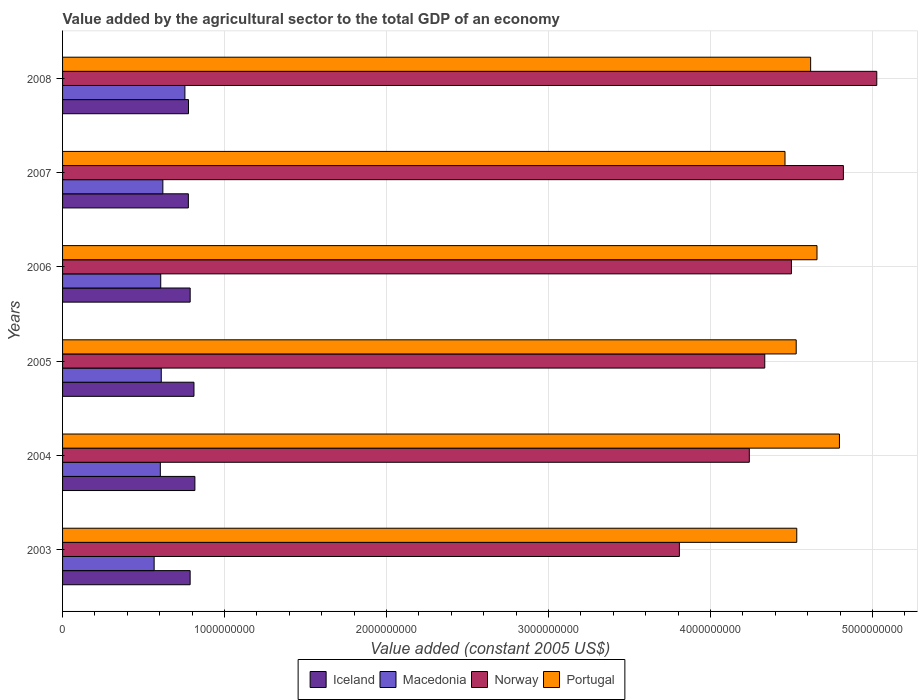How many different coloured bars are there?
Give a very brief answer. 4. How many groups of bars are there?
Your answer should be very brief. 6. How many bars are there on the 2nd tick from the top?
Provide a succinct answer. 4. How many bars are there on the 4th tick from the bottom?
Make the answer very short. 4. In how many cases, is the number of bars for a given year not equal to the number of legend labels?
Your answer should be very brief. 0. What is the value added by the agricultural sector in Portugal in 2006?
Give a very brief answer. 4.66e+09. Across all years, what is the maximum value added by the agricultural sector in Macedonia?
Ensure brevity in your answer.  7.55e+08. Across all years, what is the minimum value added by the agricultural sector in Macedonia?
Provide a short and direct response. 5.65e+08. In which year was the value added by the agricultural sector in Norway maximum?
Offer a terse response. 2008. In which year was the value added by the agricultural sector in Iceland minimum?
Provide a short and direct response. 2007. What is the total value added by the agricultural sector in Iceland in the graph?
Ensure brevity in your answer.  4.76e+09. What is the difference between the value added by the agricultural sector in Macedonia in 2004 and that in 2005?
Your answer should be compact. -5.80e+06. What is the difference between the value added by the agricultural sector in Macedonia in 2005 and the value added by the agricultural sector in Portugal in 2007?
Ensure brevity in your answer.  -3.85e+09. What is the average value added by the agricultural sector in Iceland per year?
Keep it short and to the point. 7.93e+08. In the year 2004, what is the difference between the value added by the agricultural sector in Macedonia and value added by the agricultural sector in Portugal?
Make the answer very short. -4.19e+09. What is the ratio of the value added by the agricultural sector in Iceland in 2005 to that in 2006?
Ensure brevity in your answer.  1.03. Is the difference between the value added by the agricultural sector in Macedonia in 2007 and 2008 greater than the difference between the value added by the agricultural sector in Portugal in 2007 and 2008?
Your answer should be very brief. Yes. What is the difference between the highest and the second highest value added by the agricultural sector in Portugal?
Your answer should be very brief. 1.38e+08. What is the difference between the highest and the lowest value added by the agricultural sector in Macedonia?
Make the answer very short. 1.90e+08. In how many years, is the value added by the agricultural sector in Norway greater than the average value added by the agricultural sector in Norway taken over all years?
Your answer should be compact. 3. What does the 3rd bar from the top in 2003 represents?
Your answer should be compact. Macedonia. Is it the case that in every year, the sum of the value added by the agricultural sector in Macedonia and value added by the agricultural sector in Iceland is greater than the value added by the agricultural sector in Portugal?
Your answer should be very brief. No. How many bars are there?
Make the answer very short. 24. How many years are there in the graph?
Ensure brevity in your answer.  6. What is the difference between two consecutive major ticks on the X-axis?
Make the answer very short. 1.00e+09. Are the values on the major ticks of X-axis written in scientific E-notation?
Offer a terse response. No. Does the graph contain any zero values?
Make the answer very short. No. Does the graph contain grids?
Offer a terse response. Yes. Where does the legend appear in the graph?
Provide a succinct answer. Bottom center. How are the legend labels stacked?
Your answer should be compact. Horizontal. What is the title of the graph?
Make the answer very short. Value added by the agricultural sector to the total GDP of an economy. Does "Panama" appear as one of the legend labels in the graph?
Keep it short and to the point. No. What is the label or title of the X-axis?
Keep it short and to the point. Value added (constant 2005 US$). What is the label or title of the Y-axis?
Keep it short and to the point. Years. What is the Value added (constant 2005 US$) in Iceland in 2003?
Your response must be concise. 7.88e+08. What is the Value added (constant 2005 US$) of Macedonia in 2003?
Offer a very short reply. 5.65e+08. What is the Value added (constant 2005 US$) of Norway in 2003?
Your answer should be compact. 3.81e+09. What is the Value added (constant 2005 US$) of Portugal in 2003?
Keep it short and to the point. 4.53e+09. What is the Value added (constant 2005 US$) of Iceland in 2004?
Offer a very short reply. 8.17e+08. What is the Value added (constant 2005 US$) of Macedonia in 2004?
Keep it short and to the point. 6.04e+08. What is the Value added (constant 2005 US$) in Norway in 2004?
Offer a very short reply. 4.24e+09. What is the Value added (constant 2005 US$) of Portugal in 2004?
Provide a short and direct response. 4.80e+09. What is the Value added (constant 2005 US$) of Iceland in 2005?
Offer a very short reply. 8.11e+08. What is the Value added (constant 2005 US$) in Macedonia in 2005?
Keep it short and to the point. 6.09e+08. What is the Value added (constant 2005 US$) of Norway in 2005?
Ensure brevity in your answer.  4.33e+09. What is the Value added (constant 2005 US$) in Portugal in 2005?
Make the answer very short. 4.53e+09. What is the Value added (constant 2005 US$) in Iceland in 2006?
Your answer should be compact. 7.88e+08. What is the Value added (constant 2005 US$) in Macedonia in 2006?
Provide a succinct answer. 6.06e+08. What is the Value added (constant 2005 US$) in Norway in 2006?
Provide a succinct answer. 4.50e+09. What is the Value added (constant 2005 US$) of Portugal in 2006?
Your response must be concise. 4.66e+09. What is the Value added (constant 2005 US$) in Iceland in 2007?
Provide a short and direct response. 7.77e+08. What is the Value added (constant 2005 US$) of Macedonia in 2007?
Your response must be concise. 6.19e+08. What is the Value added (constant 2005 US$) of Norway in 2007?
Give a very brief answer. 4.82e+09. What is the Value added (constant 2005 US$) of Portugal in 2007?
Ensure brevity in your answer.  4.46e+09. What is the Value added (constant 2005 US$) in Iceland in 2008?
Provide a succinct answer. 7.77e+08. What is the Value added (constant 2005 US$) in Macedonia in 2008?
Offer a very short reply. 7.55e+08. What is the Value added (constant 2005 US$) of Norway in 2008?
Your response must be concise. 5.03e+09. What is the Value added (constant 2005 US$) of Portugal in 2008?
Provide a short and direct response. 4.62e+09. Across all years, what is the maximum Value added (constant 2005 US$) of Iceland?
Your response must be concise. 8.17e+08. Across all years, what is the maximum Value added (constant 2005 US$) in Macedonia?
Your answer should be very brief. 7.55e+08. Across all years, what is the maximum Value added (constant 2005 US$) in Norway?
Your answer should be very brief. 5.03e+09. Across all years, what is the maximum Value added (constant 2005 US$) of Portugal?
Keep it short and to the point. 4.80e+09. Across all years, what is the minimum Value added (constant 2005 US$) of Iceland?
Offer a very short reply. 7.77e+08. Across all years, what is the minimum Value added (constant 2005 US$) in Macedonia?
Give a very brief answer. 5.65e+08. Across all years, what is the minimum Value added (constant 2005 US$) in Norway?
Keep it short and to the point. 3.81e+09. Across all years, what is the minimum Value added (constant 2005 US$) of Portugal?
Provide a short and direct response. 4.46e+09. What is the total Value added (constant 2005 US$) of Iceland in the graph?
Offer a very short reply. 4.76e+09. What is the total Value added (constant 2005 US$) of Macedonia in the graph?
Your answer should be very brief. 3.76e+09. What is the total Value added (constant 2005 US$) of Norway in the graph?
Provide a succinct answer. 2.67e+1. What is the total Value added (constant 2005 US$) in Portugal in the graph?
Your answer should be very brief. 2.76e+1. What is the difference between the Value added (constant 2005 US$) in Iceland in 2003 and that in 2004?
Provide a short and direct response. -2.93e+07. What is the difference between the Value added (constant 2005 US$) of Macedonia in 2003 and that in 2004?
Ensure brevity in your answer.  -3.82e+07. What is the difference between the Value added (constant 2005 US$) of Norway in 2003 and that in 2004?
Your response must be concise. -4.32e+08. What is the difference between the Value added (constant 2005 US$) of Portugal in 2003 and that in 2004?
Your answer should be compact. -2.63e+08. What is the difference between the Value added (constant 2005 US$) of Iceland in 2003 and that in 2005?
Your answer should be very brief. -2.36e+07. What is the difference between the Value added (constant 2005 US$) in Macedonia in 2003 and that in 2005?
Make the answer very short. -4.40e+07. What is the difference between the Value added (constant 2005 US$) of Norway in 2003 and that in 2005?
Ensure brevity in your answer.  -5.27e+08. What is the difference between the Value added (constant 2005 US$) in Portugal in 2003 and that in 2005?
Provide a short and direct response. 3.53e+06. What is the difference between the Value added (constant 2005 US$) in Iceland in 2003 and that in 2006?
Offer a very short reply. -1.22e+05. What is the difference between the Value added (constant 2005 US$) of Macedonia in 2003 and that in 2006?
Your response must be concise. -4.07e+07. What is the difference between the Value added (constant 2005 US$) in Norway in 2003 and that in 2006?
Make the answer very short. -6.92e+08. What is the difference between the Value added (constant 2005 US$) of Portugal in 2003 and that in 2006?
Ensure brevity in your answer.  -1.25e+08. What is the difference between the Value added (constant 2005 US$) of Iceland in 2003 and that in 2007?
Make the answer very short. 1.11e+07. What is the difference between the Value added (constant 2005 US$) of Macedonia in 2003 and that in 2007?
Give a very brief answer. -5.37e+07. What is the difference between the Value added (constant 2005 US$) of Norway in 2003 and that in 2007?
Offer a very short reply. -1.01e+09. What is the difference between the Value added (constant 2005 US$) in Portugal in 2003 and that in 2007?
Keep it short and to the point. 7.26e+07. What is the difference between the Value added (constant 2005 US$) of Iceland in 2003 and that in 2008?
Offer a terse response. 1.02e+07. What is the difference between the Value added (constant 2005 US$) in Macedonia in 2003 and that in 2008?
Your response must be concise. -1.90e+08. What is the difference between the Value added (constant 2005 US$) in Norway in 2003 and that in 2008?
Provide a succinct answer. -1.22e+09. What is the difference between the Value added (constant 2005 US$) of Portugal in 2003 and that in 2008?
Your response must be concise. -8.56e+07. What is the difference between the Value added (constant 2005 US$) in Iceland in 2004 and that in 2005?
Your answer should be very brief. 5.69e+06. What is the difference between the Value added (constant 2005 US$) of Macedonia in 2004 and that in 2005?
Your answer should be compact. -5.80e+06. What is the difference between the Value added (constant 2005 US$) in Norway in 2004 and that in 2005?
Offer a very short reply. -9.55e+07. What is the difference between the Value added (constant 2005 US$) in Portugal in 2004 and that in 2005?
Provide a short and direct response. 2.67e+08. What is the difference between the Value added (constant 2005 US$) in Iceland in 2004 and that in 2006?
Ensure brevity in your answer.  2.92e+07. What is the difference between the Value added (constant 2005 US$) in Macedonia in 2004 and that in 2006?
Provide a succinct answer. -2.50e+06. What is the difference between the Value added (constant 2005 US$) in Norway in 2004 and that in 2006?
Ensure brevity in your answer.  -2.60e+08. What is the difference between the Value added (constant 2005 US$) of Portugal in 2004 and that in 2006?
Offer a very short reply. 1.38e+08. What is the difference between the Value added (constant 2005 US$) in Iceland in 2004 and that in 2007?
Your answer should be compact. 4.04e+07. What is the difference between the Value added (constant 2005 US$) in Macedonia in 2004 and that in 2007?
Provide a succinct answer. -1.56e+07. What is the difference between the Value added (constant 2005 US$) in Norway in 2004 and that in 2007?
Provide a succinct answer. -5.81e+08. What is the difference between the Value added (constant 2005 US$) of Portugal in 2004 and that in 2007?
Provide a short and direct response. 3.36e+08. What is the difference between the Value added (constant 2005 US$) in Iceland in 2004 and that in 2008?
Your answer should be very brief. 3.94e+07. What is the difference between the Value added (constant 2005 US$) in Macedonia in 2004 and that in 2008?
Offer a very short reply. -1.52e+08. What is the difference between the Value added (constant 2005 US$) of Norway in 2004 and that in 2008?
Keep it short and to the point. -7.87e+08. What is the difference between the Value added (constant 2005 US$) of Portugal in 2004 and that in 2008?
Give a very brief answer. 1.78e+08. What is the difference between the Value added (constant 2005 US$) in Iceland in 2005 and that in 2006?
Give a very brief answer. 2.35e+07. What is the difference between the Value added (constant 2005 US$) in Macedonia in 2005 and that in 2006?
Offer a very short reply. 3.31e+06. What is the difference between the Value added (constant 2005 US$) in Norway in 2005 and that in 2006?
Provide a succinct answer. -1.65e+08. What is the difference between the Value added (constant 2005 US$) of Portugal in 2005 and that in 2006?
Your answer should be compact. -1.28e+08. What is the difference between the Value added (constant 2005 US$) of Iceland in 2005 and that in 2007?
Offer a very short reply. 3.47e+07. What is the difference between the Value added (constant 2005 US$) in Macedonia in 2005 and that in 2007?
Give a very brief answer. -9.75e+06. What is the difference between the Value added (constant 2005 US$) in Norway in 2005 and that in 2007?
Offer a terse response. -4.85e+08. What is the difference between the Value added (constant 2005 US$) in Portugal in 2005 and that in 2007?
Your answer should be compact. 6.91e+07. What is the difference between the Value added (constant 2005 US$) of Iceland in 2005 and that in 2008?
Make the answer very short. 3.37e+07. What is the difference between the Value added (constant 2005 US$) in Macedonia in 2005 and that in 2008?
Offer a very short reply. -1.46e+08. What is the difference between the Value added (constant 2005 US$) in Norway in 2005 and that in 2008?
Give a very brief answer. -6.92e+08. What is the difference between the Value added (constant 2005 US$) of Portugal in 2005 and that in 2008?
Provide a short and direct response. -8.92e+07. What is the difference between the Value added (constant 2005 US$) of Iceland in 2006 and that in 2007?
Ensure brevity in your answer.  1.12e+07. What is the difference between the Value added (constant 2005 US$) of Macedonia in 2006 and that in 2007?
Offer a terse response. -1.31e+07. What is the difference between the Value added (constant 2005 US$) of Norway in 2006 and that in 2007?
Provide a succinct answer. -3.21e+08. What is the difference between the Value added (constant 2005 US$) of Portugal in 2006 and that in 2007?
Provide a succinct answer. 1.98e+08. What is the difference between the Value added (constant 2005 US$) in Iceland in 2006 and that in 2008?
Ensure brevity in your answer.  1.03e+07. What is the difference between the Value added (constant 2005 US$) in Macedonia in 2006 and that in 2008?
Provide a succinct answer. -1.49e+08. What is the difference between the Value added (constant 2005 US$) in Norway in 2006 and that in 2008?
Ensure brevity in your answer.  -5.27e+08. What is the difference between the Value added (constant 2005 US$) of Portugal in 2006 and that in 2008?
Your answer should be very brief. 3.93e+07. What is the difference between the Value added (constant 2005 US$) of Iceland in 2007 and that in 2008?
Offer a terse response. -9.22e+05. What is the difference between the Value added (constant 2005 US$) in Macedonia in 2007 and that in 2008?
Offer a very short reply. -1.36e+08. What is the difference between the Value added (constant 2005 US$) of Norway in 2007 and that in 2008?
Offer a terse response. -2.06e+08. What is the difference between the Value added (constant 2005 US$) of Portugal in 2007 and that in 2008?
Make the answer very short. -1.58e+08. What is the difference between the Value added (constant 2005 US$) of Iceland in 2003 and the Value added (constant 2005 US$) of Macedonia in 2004?
Keep it short and to the point. 1.84e+08. What is the difference between the Value added (constant 2005 US$) in Iceland in 2003 and the Value added (constant 2005 US$) in Norway in 2004?
Provide a short and direct response. -3.45e+09. What is the difference between the Value added (constant 2005 US$) in Iceland in 2003 and the Value added (constant 2005 US$) in Portugal in 2004?
Offer a very short reply. -4.01e+09. What is the difference between the Value added (constant 2005 US$) of Macedonia in 2003 and the Value added (constant 2005 US$) of Norway in 2004?
Keep it short and to the point. -3.67e+09. What is the difference between the Value added (constant 2005 US$) in Macedonia in 2003 and the Value added (constant 2005 US$) in Portugal in 2004?
Give a very brief answer. -4.23e+09. What is the difference between the Value added (constant 2005 US$) in Norway in 2003 and the Value added (constant 2005 US$) in Portugal in 2004?
Offer a terse response. -9.88e+08. What is the difference between the Value added (constant 2005 US$) of Iceland in 2003 and the Value added (constant 2005 US$) of Macedonia in 2005?
Your answer should be very brief. 1.78e+08. What is the difference between the Value added (constant 2005 US$) of Iceland in 2003 and the Value added (constant 2005 US$) of Norway in 2005?
Your answer should be very brief. -3.55e+09. What is the difference between the Value added (constant 2005 US$) in Iceland in 2003 and the Value added (constant 2005 US$) in Portugal in 2005?
Offer a very short reply. -3.74e+09. What is the difference between the Value added (constant 2005 US$) in Macedonia in 2003 and the Value added (constant 2005 US$) in Norway in 2005?
Provide a short and direct response. -3.77e+09. What is the difference between the Value added (constant 2005 US$) in Macedonia in 2003 and the Value added (constant 2005 US$) in Portugal in 2005?
Provide a succinct answer. -3.96e+09. What is the difference between the Value added (constant 2005 US$) in Norway in 2003 and the Value added (constant 2005 US$) in Portugal in 2005?
Ensure brevity in your answer.  -7.21e+08. What is the difference between the Value added (constant 2005 US$) of Iceland in 2003 and the Value added (constant 2005 US$) of Macedonia in 2006?
Keep it short and to the point. 1.82e+08. What is the difference between the Value added (constant 2005 US$) in Iceland in 2003 and the Value added (constant 2005 US$) in Norway in 2006?
Ensure brevity in your answer.  -3.71e+09. What is the difference between the Value added (constant 2005 US$) of Iceland in 2003 and the Value added (constant 2005 US$) of Portugal in 2006?
Offer a very short reply. -3.87e+09. What is the difference between the Value added (constant 2005 US$) of Macedonia in 2003 and the Value added (constant 2005 US$) of Norway in 2006?
Your answer should be very brief. -3.93e+09. What is the difference between the Value added (constant 2005 US$) of Macedonia in 2003 and the Value added (constant 2005 US$) of Portugal in 2006?
Your answer should be very brief. -4.09e+09. What is the difference between the Value added (constant 2005 US$) of Norway in 2003 and the Value added (constant 2005 US$) of Portugal in 2006?
Your answer should be compact. -8.50e+08. What is the difference between the Value added (constant 2005 US$) of Iceland in 2003 and the Value added (constant 2005 US$) of Macedonia in 2007?
Offer a terse response. 1.69e+08. What is the difference between the Value added (constant 2005 US$) of Iceland in 2003 and the Value added (constant 2005 US$) of Norway in 2007?
Provide a short and direct response. -4.03e+09. What is the difference between the Value added (constant 2005 US$) in Iceland in 2003 and the Value added (constant 2005 US$) in Portugal in 2007?
Your answer should be very brief. -3.67e+09. What is the difference between the Value added (constant 2005 US$) of Macedonia in 2003 and the Value added (constant 2005 US$) of Norway in 2007?
Provide a short and direct response. -4.25e+09. What is the difference between the Value added (constant 2005 US$) in Macedonia in 2003 and the Value added (constant 2005 US$) in Portugal in 2007?
Make the answer very short. -3.89e+09. What is the difference between the Value added (constant 2005 US$) of Norway in 2003 and the Value added (constant 2005 US$) of Portugal in 2007?
Give a very brief answer. -6.52e+08. What is the difference between the Value added (constant 2005 US$) in Iceland in 2003 and the Value added (constant 2005 US$) in Macedonia in 2008?
Make the answer very short. 3.24e+07. What is the difference between the Value added (constant 2005 US$) of Iceland in 2003 and the Value added (constant 2005 US$) of Norway in 2008?
Your response must be concise. -4.24e+09. What is the difference between the Value added (constant 2005 US$) in Iceland in 2003 and the Value added (constant 2005 US$) in Portugal in 2008?
Offer a very short reply. -3.83e+09. What is the difference between the Value added (constant 2005 US$) in Macedonia in 2003 and the Value added (constant 2005 US$) in Norway in 2008?
Your response must be concise. -4.46e+09. What is the difference between the Value added (constant 2005 US$) of Macedonia in 2003 and the Value added (constant 2005 US$) of Portugal in 2008?
Your response must be concise. -4.05e+09. What is the difference between the Value added (constant 2005 US$) in Norway in 2003 and the Value added (constant 2005 US$) in Portugal in 2008?
Your response must be concise. -8.10e+08. What is the difference between the Value added (constant 2005 US$) of Iceland in 2004 and the Value added (constant 2005 US$) of Macedonia in 2005?
Make the answer very short. 2.08e+08. What is the difference between the Value added (constant 2005 US$) in Iceland in 2004 and the Value added (constant 2005 US$) in Norway in 2005?
Your response must be concise. -3.52e+09. What is the difference between the Value added (constant 2005 US$) of Iceland in 2004 and the Value added (constant 2005 US$) of Portugal in 2005?
Make the answer very short. -3.71e+09. What is the difference between the Value added (constant 2005 US$) of Macedonia in 2004 and the Value added (constant 2005 US$) of Norway in 2005?
Your answer should be compact. -3.73e+09. What is the difference between the Value added (constant 2005 US$) in Macedonia in 2004 and the Value added (constant 2005 US$) in Portugal in 2005?
Provide a short and direct response. -3.93e+09. What is the difference between the Value added (constant 2005 US$) in Norway in 2004 and the Value added (constant 2005 US$) in Portugal in 2005?
Give a very brief answer. -2.90e+08. What is the difference between the Value added (constant 2005 US$) in Iceland in 2004 and the Value added (constant 2005 US$) in Macedonia in 2006?
Make the answer very short. 2.11e+08. What is the difference between the Value added (constant 2005 US$) in Iceland in 2004 and the Value added (constant 2005 US$) in Norway in 2006?
Your response must be concise. -3.68e+09. What is the difference between the Value added (constant 2005 US$) in Iceland in 2004 and the Value added (constant 2005 US$) in Portugal in 2006?
Your answer should be compact. -3.84e+09. What is the difference between the Value added (constant 2005 US$) of Macedonia in 2004 and the Value added (constant 2005 US$) of Norway in 2006?
Keep it short and to the point. -3.90e+09. What is the difference between the Value added (constant 2005 US$) of Macedonia in 2004 and the Value added (constant 2005 US$) of Portugal in 2006?
Offer a very short reply. -4.05e+09. What is the difference between the Value added (constant 2005 US$) in Norway in 2004 and the Value added (constant 2005 US$) in Portugal in 2006?
Your response must be concise. -4.18e+08. What is the difference between the Value added (constant 2005 US$) of Iceland in 2004 and the Value added (constant 2005 US$) of Macedonia in 2007?
Give a very brief answer. 1.98e+08. What is the difference between the Value added (constant 2005 US$) in Iceland in 2004 and the Value added (constant 2005 US$) in Norway in 2007?
Offer a very short reply. -4.00e+09. What is the difference between the Value added (constant 2005 US$) in Iceland in 2004 and the Value added (constant 2005 US$) in Portugal in 2007?
Ensure brevity in your answer.  -3.64e+09. What is the difference between the Value added (constant 2005 US$) of Macedonia in 2004 and the Value added (constant 2005 US$) of Norway in 2007?
Offer a terse response. -4.22e+09. What is the difference between the Value added (constant 2005 US$) of Macedonia in 2004 and the Value added (constant 2005 US$) of Portugal in 2007?
Make the answer very short. -3.86e+09. What is the difference between the Value added (constant 2005 US$) in Norway in 2004 and the Value added (constant 2005 US$) in Portugal in 2007?
Your answer should be compact. -2.20e+08. What is the difference between the Value added (constant 2005 US$) in Iceland in 2004 and the Value added (constant 2005 US$) in Macedonia in 2008?
Ensure brevity in your answer.  6.17e+07. What is the difference between the Value added (constant 2005 US$) in Iceland in 2004 and the Value added (constant 2005 US$) in Norway in 2008?
Make the answer very short. -4.21e+09. What is the difference between the Value added (constant 2005 US$) of Iceland in 2004 and the Value added (constant 2005 US$) of Portugal in 2008?
Make the answer very short. -3.80e+09. What is the difference between the Value added (constant 2005 US$) of Macedonia in 2004 and the Value added (constant 2005 US$) of Norway in 2008?
Your answer should be very brief. -4.42e+09. What is the difference between the Value added (constant 2005 US$) in Macedonia in 2004 and the Value added (constant 2005 US$) in Portugal in 2008?
Offer a very short reply. -4.01e+09. What is the difference between the Value added (constant 2005 US$) in Norway in 2004 and the Value added (constant 2005 US$) in Portugal in 2008?
Offer a very short reply. -3.79e+08. What is the difference between the Value added (constant 2005 US$) in Iceland in 2005 and the Value added (constant 2005 US$) in Macedonia in 2006?
Your response must be concise. 2.05e+08. What is the difference between the Value added (constant 2005 US$) of Iceland in 2005 and the Value added (constant 2005 US$) of Norway in 2006?
Provide a short and direct response. -3.69e+09. What is the difference between the Value added (constant 2005 US$) in Iceland in 2005 and the Value added (constant 2005 US$) in Portugal in 2006?
Keep it short and to the point. -3.85e+09. What is the difference between the Value added (constant 2005 US$) in Macedonia in 2005 and the Value added (constant 2005 US$) in Norway in 2006?
Your answer should be very brief. -3.89e+09. What is the difference between the Value added (constant 2005 US$) in Macedonia in 2005 and the Value added (constant 2005 US$) in Portugal in 2006?
Ensure brevity in your answer.  -4.05e+09. What is the difference between the Value added (constant 2005 US$) in Norway in 2005 and the Value added (constant 2005 US$) in Portugal in 2006?
Offer a terse response. -3.22e+08. What is the difference between the Value added (constant 2005 US$) in Iceland in 2005 and the Value added (constant 2005 US$) in Macedonia in 2007?
Ensure brevity in your answer.  1.92e+08. What is the difference between the Value added (constant 2005 US$) of Iceland in 2005 and the Value added (constant 2005 US$) of Norway in 2007?
Ensure brevity in your answer.  -4.01e+09. What is the difference between the Value added (constant 2005 US$) in Iceland in 2005 and the Value added (constant 2005 US$) in Portugal in 2007?
Your answer should be very brief. -3.65e+09. What is the difference between the Value added (constant 2005 US$) of Macedonia in 2005 and the Value added (constant 2005 US$) of Norway in 2007?
Provide a short and direct response. -4.21e+09. What is the difference between the Value added (constant 2005 US$) in Macedonia in 2005 and the Value added (constant 2005 US$) in Portugal in 2007?
Your response must be concise. -3.85e+09. What is the difference between the Value added (constant 2005 US$) of Norway in 2005 and the Value added (constant 2005 US$) of Portugal in 2007?
Give a very brief answer. -1.25e+08. What is the difference between the Value added (constant 2005 US$) of Iceland in 2005 and the Value added (constant 2005 US$) of Macedonia in 2008?
Ensure brevity in your answer.  5.60e+07. What is the difference between the Value added (constant 2005 US$) of Iceland in 2005 and the Value added (constant 2005 US$) of Norway in 2008?
Provide a succinct answer. -4.22e+09. What is the difference between the Value added (constant 2005 US$) in Iceland in 2005 and the Value added (constant 2005 US$) in Portugal in 2008?
Your answer should be compact. -3.81e+09. What is the difference between the Value added (constant 2005 US$) in Macedonia in 2005 and the Value added (constant 2005 US$) in Norway in 2008?
Your answer should be compact. -4.42e+09. What is the difference between the Value added (constant 2005 US$) in Macedonia in 2005 and the Value added (constant 2005 US$) in Portugal in 2008?
Your response must be concise. -4.01e+09. What is the difference between the Value added (constant 2005 US$) in Norway in 2005 and the Value added (constant 2005 US$) in Portugal in 2008?
Ensure brevity in your answer.  -2.83e+08. What is the difference between the Value added (constant 2005 US$) of Iceland in 2006 and the Value added (constant 2005 US$) of Macedonia in 2007?
Provide a short and direct response. 1.69e+08. What is the difference between the Value added (constant 2005 US$) in Iceland in 2006 and the Value added (constant 2005 US$) in Norway in 2007?
Your answer should be very brief. -4.03e+09. What is the difference between the Value added (constant 2005 US$) of Iceland in 2006 and the Value added (constant 2005 US$) of Portugal in 2007?
Ensure brevity in your answer.  -3.67e+09. What is the difference between the Value added (constant 2005 US$) in Macedonia in 2006 and the Value added (constant 2005 US$) in Norway in 2007?
Ensure brevity in your answer.  -4.21e+09. What is the difference between the Value added (constant 2005 US$) of Macedonia in 2006 and the Value added (constant 2005 US$) of Portugal in 2007?
Your answer should be very brief. -3.85e+09. What is the difference between the Value added (constant 2005 US$) of Norway in 2006 and the Value added (constant 2005 US$) of Portugal in 2007?
Your answer should be very brief. 3.96e+07. What is the difference between the Value added (constant 2005 US$) in Iceland in 2006 and the Value added (constant 2005 US$) in Macedonia in 2008?
Keep it short and to the point. 3.25e+07. What is the difference between the Value added (constant 2005 US$) in Iceland in 2006 and the Value added (constant 2005 US$) in Norway in 2008?
Your response must be concise. -4.24e+09. What is the difference between the Value added (constant 2005 US$) in Iceland in 2006 and the Value added (constant 2005 US$) in Portugal in 2008?
Your response must be concise. -3.83e+09. What is the difference between the Value added (constant 2005 US$) of Macedonia in 2006 and the Value added (constant 2005 US$) of Norway in 2008?
Provide a succinct answer. -4.42e+09. What is the difference between the Value added (constant 2005 US$) of Macedonia in 2006 and the Value added (constant 2005 US$) of Portugal in 2008?
Give a very brief answer. -4.01e+09. What is the difference between the Value added (constant 2005 US$) of Norway in 2006 and the Value added (constant 2005 US$) of Portugal in 2008?
Offer a terse response. -1.19e+08. What is the difference between the Value added (constant 2005 US$) of Iceland in 2007 and the Value added (constant 2005 US$) of Macedonia in 2008?
Your answer should be very brief. 2.13e+07. What is the difference between the Value added (constant 2005 US$) in Iceland in 2007 and the Value added (constant 2005 US$) in Norway in 2008?
Your answer should be compact. -4.25e+09. What is the difference between the Value added (constant 2005 US$) in Iceland in 2007 and the Value added (constant 2005 US$) in Portugal in 2008?
Your answer should be compact. -3.84e+09. What is the difference between the Value added (constant 2005 US$) in Macedonia in 2007 and the Value added (constant 2005 US$) in Norway in 2008?
Your response must be concise. -4.41e+09. What is the difference between the Value added (constant 2005 US$) of Macedonia in 2007 and the Value added (constant 2005 US$) of Portugal in 2008?
Offer a very short reply. -4.00e+09. What is the difference between the Value added (constant 2005 US$) of Norway in 2007 and the Value added (constant 2005 US$) of Portugal in 2008?
Ensure brevity in your answer.  2.02e+08. What is the average Value added (constant 2005 US$) in Iceland per year?
Give a very brief answer. 7.93e+08. What is the average Value added (constant 2005 US$) in Macedonia per year?
Your response must be concise. 6.26e+08. What is the average Value added (constant 2005 US$) of Norway per year?
Keep it short and to the point. 4.45e+09. What is the average Value added (constant 2005 US$) of Portugal per year?
Offer a very short reply. 4.60e+09. In the year 2003, what is the difference between the Value added (constant 2005 US$) in Iceland and Value added (constant 2005 US$) in Macedonia?
Offer a very short reply. 2.22e+08. In the year 2003, what is the difference between the Value added (constant 2005 US$) in Iceland and Value added (constant 2005 US$) in Norway?
Offer a very short reply. -3.02e+09. In the year 2003, what is the difference between the Value added (constant 2005 US$) of Iceland and Value added (constant 2005 US$) of Portugal?
Your answer should be compact. -3.74e+09. In the year 2003, what is the difference between the Value added (constant 2005 US$) of Macedonia and Value added (constant 2005 US$) of Norway?
Give a very brief answer. -3.24e+09. In the year 2003, what is the difference between the Value added (constant 2005 US$) of Macedonia and Value added (constant 2005 US$) of Portugal?
Keep it short and to the point. -3.97e+09. In the year 2003, what is the difference between the Value added (constant 2005 US$) in Norway and Value added (constant 2005 US$) in Portugal?
Your answer should be compact. -7.25e+08. In the year 2004, what is the difference between the Value added (constant 2005 US$) of Iceland and Value added (constant 2005 US$) of Macedonia?
Give a very brief answer. 2.13e+08. In the year 2004, what is the difference between the Value added (constant 2005 US$) of Iceland and Value added (constant 2005 US$) of Norway?
Offer a very short reply. -3.42e+09. In the year 2004, what is the difference between the Value added (constant 2005 US$) of Iceland and Value added (constant 2005 US$) of Portugal?
Offer a terse response. -3.98e+09. In the year 2004, what is the difference between the Value added (constant 2005 US$) of Macedonia and Value added (constant 2005 US$) of Norway?
Your response must be concise. -3.64e+09. In the year 2004, what is the difference between the Value added (constant 2005 US$) in Macedonia and Value added (constant 2005 US$) in Portugal?
Ensure brevity in your answer.  -4.19e+09. In the year 2004, what is the difference between the Value added (constant 2005 US$) in Norway and Value added (constant 2005 US$) in Portugal?
Provide a succinct answer. -5.56e+08. In the year 2005, what is the difference between the Value added (constant 2005 US$) in Iceland and Value added (constant 2005 US$) in Macedonia?
Your answer should be compact. 2.02e+08. In the year 2005, what is the difference between the Value added (constant 2005 US$) in Iceland and Value added (constant 2005 US$) in Norway?
Your response must be concise. -3.52e+09. In the year 2005, what is the difference between the Value added (constant 2005 US$) in Iceland and Value added (constant 2005 US$) in Portugal?
Your answer should be very brief. -3.72e+09. In the year 2005, what is the difference between the Value added (constant 2005 US$) of Macedonia and Value added (constant 2005 US$) of Norway?
Make the answer very short. -3.73e+09. In the year 2005, what is the difference between the Value added (constant 2005 US$) in Macedonia and Value added (constant 2005 US$) in Portugal?
Keep it short and to the point. -3.92e+09. In the year 2005, what is the difference between the Value added (constant 2005 US$) of Norway and Value added (constant 2005 US$) of Portugal?
Your answer should be very brief. -1.94e+08. In the year 2006, what is the difference between the Value added (constant 2005 US$) in Iceland and Value added (constant 2005 US$) in Macedonia?
Your answer should be very brief. 1.82e+08. In the year 2006, what is the difference between the Value added (constant 2005 US$) in Iceland and Value added (constant 2005 US$) in Norway?
Provide a short and direct response. -3.71e+09. In the year 2006, what is the difference between the Value added (constant 2005 US$) in Iceland and Value added (constant 2005 US$) in Portugal?
Give a very brief answer. -3.87e+09. In the year 2006, what is the difference between the Value added (constant 2005 US$) in Macedonia and Value added (constant 2005 US$) in Norway?
Make the answer very short. -3.89e+09. In the year 2006, what is the difference between the Value added (constant 2005 US$) in Macedonia and Value added (constant 2005 US$) in Portugal?
Your answer should be compact. -4.05e+09. In the year 2006, what is the difference between the Value added (constant 2005 US$) in Norway and Value added (constant 2005 US$) in Portugal?
Ensure brevity in your answer.  -1.58e+08. In the year 2007, what is the difference between the Value added (constant 2005 US$) of Iceland and Value added (constant 2005 US$) of Macedonia?
Your response must be concise. 1.57e+08. In the year 2007, what is the difference between the Value added (constant 2005 US$) in Iceland and Value added (constant 2005 US$) in Norway?
Provide a succinct answer. -4.04e+09. In the year 2007, what is the difference between the Value added (constant 2005 US$) of Iceland and Value added (constant 2005 US$) of Portugal?
Your response must be concise. -3.68e+09. In the year 2007, what is the difference between the Value added (constant 2005 US$) of Macedonia and Value added (constant 2005 US$) of Norway?
Provide a succinct answer. -4.20e+09. In the year 2007, what is the difference between the Value added (constant 2005 US$) in Macedonia and Value added (constant 2005 US$) in Portugal?
Ensure brevity in your answer.  -3.84e+09. In the year 2007, what is the difference between the Value added (constant 2005 US$) of Norway and Value added (constant 2005 US$) of Portugal?
Offer a very short reply. 3.60e+08. In the year 2008, what is the difference between the Value added (constant 2005 US$) of Iceland and Value added (constant 2005 US$) of Macedonia?
Give a very brief answer. 2.22e+07. In the year 2008, what is the difference between the Value added (constant 2005 US$) in Iceland and Value added (constant 2005 US$) in Norway?
Keep it short and to the point. -4.25e+09. In the year 2008, what is the difference between the Value added (constant 2005 US$) of Iceland and Value added (constant 2005 US$) of Portugal?
Offer a very short reply. -3.84e+09. In the year 2008, what is the difference between the Value added (constant 2005 US$) in Macedonia and Value added (constant 2005 US$) in Norway?
Make the answer very short. -4.27e+09. In the year 2008, what is the difference between the Value added (constant 2005 US$) of Macedonia and Value added (constant 2005 US$) of Portugal?
Your answer should be compact. -3.86e+09. In the year 2008, what is the difference between the Value added (constant 2005 US$) of Norway and Value added (constant 2005 US$) of Portugal?
Make the answer very short. 4.08e+08. What is the ratio of the Value added (constant 2005 US$) in Iceland in 2003 to that in 2004?
Give a very brief answer. 0.96. What is the ratio of the Value added (constant 2005 US$) in Macedonia in 2003 to that in 2004?
Offer a terse response. 0.94. What is the ratio of the Value added (constant 2005 US$) in Norway in 2003 to that in 2004?
Provide a short and direct response. 0.9. What is the ratio of the Value added (constant 2005 US$) of Portugal in 2003 to that in 2004?
Give a very brief answer. 0.95. What is the ratio of the Value added (constant 2005 US$) in Iceland in 2003 to that in 2005?
Provide a succinct answer. 0.97. What is the ratio of the Value added (constant 2005 US$) in Macedonia in 2003 to that in 2005?
Your answer should be very brief. 0.93. What is the ratio of the Value added (constant 2005 US$) in Norway in 2003 to that in 2005?
Make the answer very short. 0.88. What is the ratio of the Value added (constant 2005 US$) in Iceland in 2003 to that in 2006?
Your answer should be very brief. 1. What is the ratio of the Value added (constant 2005 US$) in Macedonia in 2003 to that in 2006?
Provide a succinct answer. 0.93. What is the ratio of the Value added (constant 2005 US$) of Norway in 2003 to that in 2006?
Offer a terse response. 0.85. What is the ratio of the Value added (constant 2005 US$) in Portugal in 2003 to that in 2006?
Offer a terse response. 0.97. What is the ratio of the Value added (constant 2005 US$) of Iceland in 2003 to that in 2007?
Provide a short and direct response. 1.01. What is the ratio of the Value added (constant 2005 US$) in Macedonia in 2003 to that in 2007?
Provide a short and direct response. 0.91. What is the ratio of the Value added (constant 2005 US$) in Norway in 2003 to that in 2007?
Ensure brevity in your answer.  0.79. What is the ratio of the Value added (constant 2005 US$) of Portugal in 2003 to that in 2007?
Give a very brief answer. 1.02. What is the ratio of the Value added (constant 2005 US$) of Iceland in 2003 to that in 2008?
Your answer should be very brief. 1.01. What is the ratio of the Value added (constant 2005 US$) in Macedonia in 2003 to that in 2008?
Your answer should be very brief. 0.75. What is the ratio of the Value added (constant 2005 US$) in Norway in 2003 to that in 2008?
Make the answer very short. 0.76. What is the ratio of the Value added (constant 2005 US$) in Portugal in 2003 to that in 2008?
Provide a succinct answer. 0.98. What is the ratio of the Value added (constant 2005 US$) in Portugal in 2004 to that in 2005?
Your response must be concise. 1.06. What is the ratio of the Value added (constant 2005 US$) in Iceland in 2004 to that in 2006?
Keep it short and to the point. 1.04. What is the ratio of the Value added (constant 2005 US$) in Norway in 2004 to that in 2006?
Make the answer very short. 0.94. What is the ratio of the Value added (constant 2005 US$) of Portugal in 2004 to that in 2006?
Offer a very short reply. 1.03. What is the ratio of the Value added (constant 2005 US$) of Iceland in 2004 to that in 2007?
Make the answer very short. 1.05. What is the ratio of the Value added (constant 2005 US$) in Macedonia in 2004 to that in 2007?
Your answer should be compact. 0.97. What is the ratio of the Value added (constant 2005 US$) in Norway in 2004 to that in 2007?
Provide a short and direct response. 0.88. What is the ratio of the Value added (constant 2005 US$) of Portugal in 2004 to that in 2007?
Provide a succinct answer. 1.08. What is the ratio of the Value added (constant 2005 US$) of Iceland in 2004 to that in 2008?
Provide a succinct answer. 1.05. What is the ratio of the Value added (constant 2005 US$) of Macedonia in 2004 to that in 2008?
Ensure brevity in your answer.  0.8. What is the ratio of the Value added (constant 2005 US$) in Norway in 2004 to that in 2008?
Your answer should be compact. 0.84. What is the ratio of the Value added (constant 2005 US$) in Portugal in 2004 to that in 2008?
Offer a very short reply. 1.04. What is the ratio of the Value added (constant 2005 US$) in Iceland in 2005 to that in 2006?
Your answer should be very brief. 1.03. What is the ratio of the Value added (constant 2005 US$) of Macedonia in 2005 to that in 2006?
Offer a terse response. 1.01. What is the ratio of the Value added (constant 2005 US$) in Norway in 2005 to that in 2006?
Keep it short and to the point. 0.96. What is the ratio of the Value added (constant 2005 US$) in Portugal in 2005 to that in 2006?
Offer a very short reply. 0.97. What is the ratio of the Value added (constant 2005 US$) in Iceland in 2005 to that in 2007?
Ensure brevity in your answer.  1.04. What is the ratio of the Value added (constant 2005 US$) in Macedonia in 2005 to that in 2007?
Keep it short and to the point. 0.98. What is the ratio of the Value added (constant 2005 US$) of Norway in 2005 to that in 2007?
Offer a terse response. 0.9. What is the ratio of the Value added (constant 2005 US$) in Portugal in 2005 to that in 2007?
Provide a short and direct response. 1.02. What is the ratio of the Value added (constant 2005 US$) of Iceland in 2005 to that in 2008?
Provide a succinct answer. 1.04. What is the ratio of the Value added (constant 2005 US$) of Macedonia in 2005 to that in 2008?
Ensure brevity in your answer.  0.81. What is the ratio of the Value added (constant 2005 US$) of Norway in 2005 to that in 2008?
Ensure brevity in your answer.  0.86. What is the ratio of the Value added (constant 2005 US$) of Portugal in 2005 to that in 2008?
Make the answer very short. 0.98. What is the ratio of the Value added (constant 2005 US$) in Iceland in 2006 to that in 2007?
Offer a terse response. 1.01. What is the ratio of the Value added (constant 2005 US$) in Macedonia in 2006 to that in 2007?
Keep it short and to the point. 0.98. What is the ratio of the Value added (constant 2005 US$) in Norway in 2006 to that in 2007?
Provide a short and direct response. 0.93. What is the ratio of the Value added (constant 2005 US$) in Portugal in 2006 to that in 2007?
Keep it short and to the point. 1.04. What is the ratio of the Value added (constant 2005 US$) of Iceland in 2006 to that in 2008?
Your response must be concise. 1.01. What is the ratio of the Value added (constant 2005 US$) of Macedonia in 2006 to that in 2008?
Ensure brevity in your answer.  0.8. What is the ratio of the Value added (constant 2005 US$) of Norway in 2006 to that in 2008?
Give a very brief answer. 0.9. What is the ratio of the Value added (constant 2005 US$) of Portugal in 2006 to that in 2008?
Ensure brevity in your answer.  1.01. What is the ratio of the Value added (constant 2005 US$) of Macedonia in 2007 to that in 2008?
Give a very brief answer. 0.82. What is the ratio of the Value added (constant 2005 US$) in Norway in 2007 to that in 2008?
Your response must be concise. 0.96. What is the ratio of the Value added (constant 2005 US$) of Portugal in 2007 to that in 2008?
Give a very brief answer. 0.97. What is the difference between the highest and the second highest Value added (constant 2005 US$) of Iceland?
Give a very brief answer. 5.69e+06. What is the difference between the highest and the second highest Value added (constant 2005 US$) in Macedonia?
Give a very brief answer. 1.36e+08. What is the difference between the highest and the second highest Value added (constant 2005 US$) of Norway?
Provide a short and direct response. 2.06e+08. What is the difference between the highest and the second highest Value added (constant 2005 US$) in Portugal?
Your answer should be very brief. 1.38e+08. What is the difference between the highest and the lowest Value added (constant 2005 US$) of Iceland?
Your answer should be compact. 4.04e+07. What is the difference between the highest and the lowest Value added (constant 2005 US$) in Macedonia?
Ensure brevity in your answer.  1.90e+08. What is the difference between the highest and the lowest Value added (constant 2005 US$) in Norway?
Keep it short and to the point. 1.22e+09. What is the difference between the highest and the lowest Value added (constant 2005 US$) of Portugal?
Make the answer very short. 3.36e+08. 